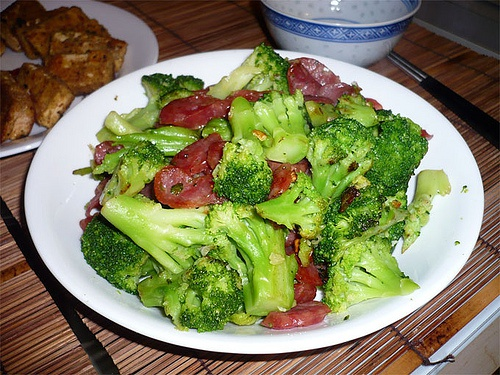Describe the objects in this image and their specific colors. I can see dining table in gray, maroon, black, and brown tones, broccoli in gray, olive, lightgreen, and darkgreen tones, broccoli in gray, darkgreen, olive, khaki, and green tones, bowl in gray, darkgray, and black tones, and broccoli in gray, khaki, lightgreen, and olive tones in this image. 